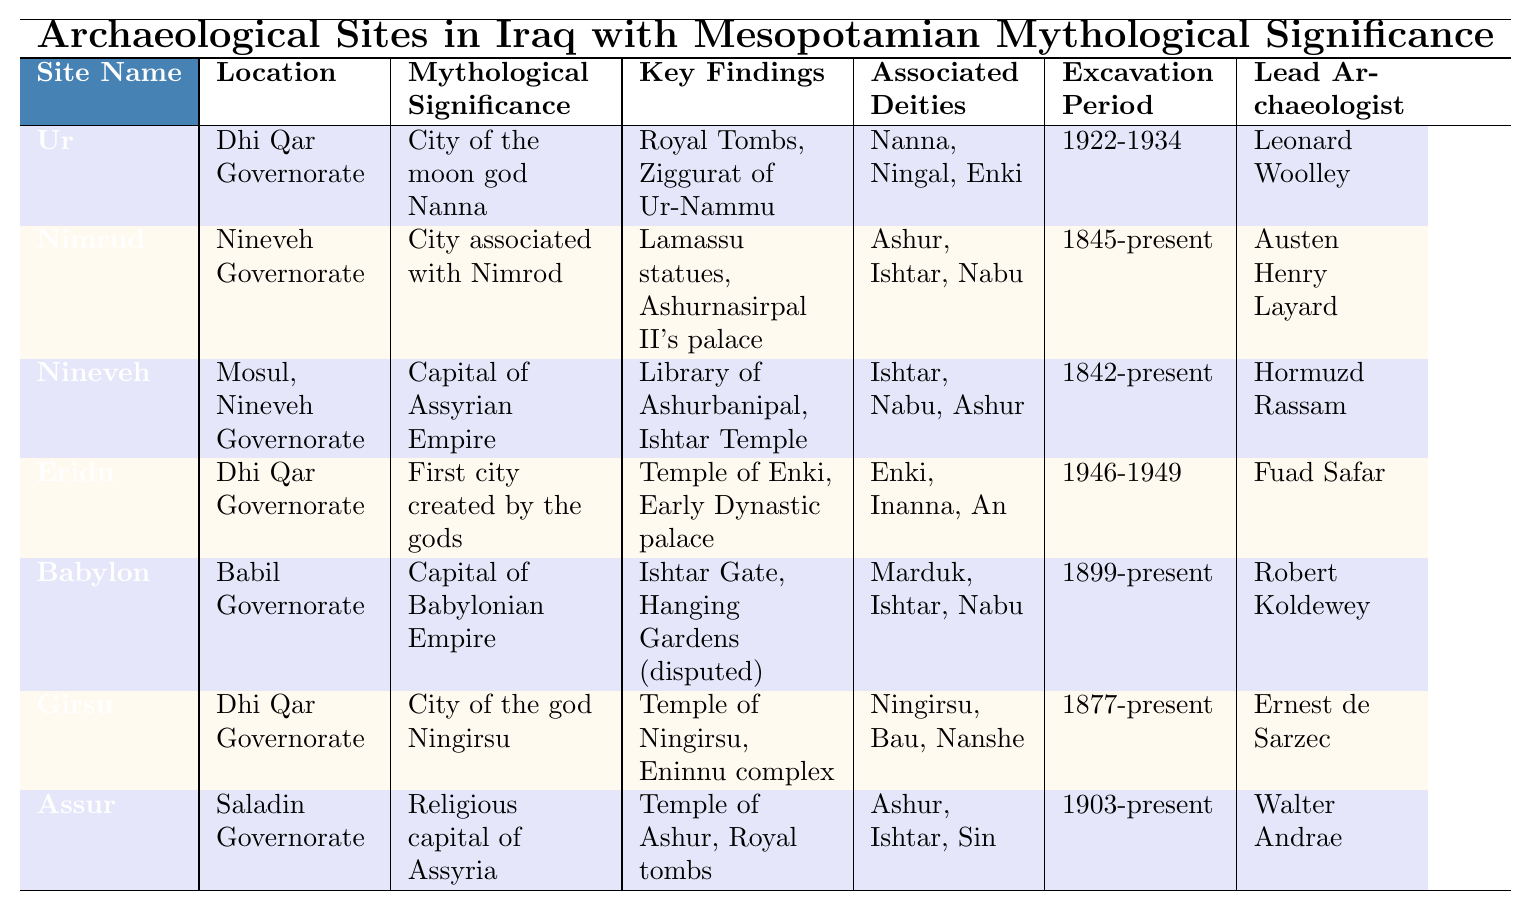What is the location of the site Ur? The table lists the location of Ur as Dhi Qar Governorate.
Answer: Dhi Qar Governorate Which archaeological site is associated with the moon god Nanna? According to the table, Ur is identified as the city of the moon god Nanna.
Answer: Ur How many archaeological sites have excavation periods starting before 1900? The sites with excavation periods before 1900 are Nimrud (1845), Nineveh (1842), and Girsu (1877), totaling three sites.
Answer: 3 What key findings are associated with the site of Babylon? The table states that the key findings at Babylon include the Ishtar Gate and the disputed Hanging Gardens.
Answer: Ishtar Gate, Hanging Gardens (disputed) Which site has been excavated by Robert Koldewey? According to the table, Robert Koldewey is the lead archaeologist for the site Babylon.
Answer: Babylon Is the Ishtar Temple found in Nineveh? The table confirms that the Ishtar Temple is indeed one of the key findings at Nineveh.
Answer: True Which site is both a city of a specific deity and also listed as a capital? According to the table, Babylon is the capital of the Babylonian Empire and associated with the deity Marduk.
Answer: Babylon During which years was the excavation of Ur performed? The table specifies that excavation at Ur took place from 1922 to 1934.
Answer: 1922-1934 Which site has the longest excavation period, still ongoing? The longest ongoing excavation is at Nimrud, which has been excavated since 1845 to the present.
Answer: Nimrud How many sites are associated with the deity Ishtar? The sites associated with Ishtar are Nimrud, Nineveh, and Assur, totaling three sites.
Answer: 3 What were the key findings at the site Girsu? The table lists the key findings at Girsu as the Temple of Ningirsu and the Eninnu complex.
Answer: Temple of Ningirsu, Eninnu complex 